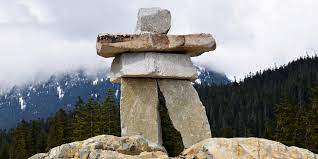What is this photo about'?
 This image captures the striking figure of an Inukshuk, a traditional stone landmark used by the Inuit people. The Inukshuk stands tall against the backdrop of a mountainous landscape, its form composed of large, flat stones stacked meticulously to resemble a human figure with outstretched arms. The stones, weathered and gray, bear the marks of time and elements, adding a sense of history and resilience to the scene. The perspective of the image, taken from a low angle, enhances the stature of the Inukshuk, making it appear as a silent guardian overlooking the forested mountain range. The mountains in the distance are adorned with snow-capped peaks, adding a touch of pristine white to the otherwise earthy color palette of the image. This landmark, standing amidst the rugged beauty of nature, serves as a testament to the rich cultural heritage of the Inuit people. 